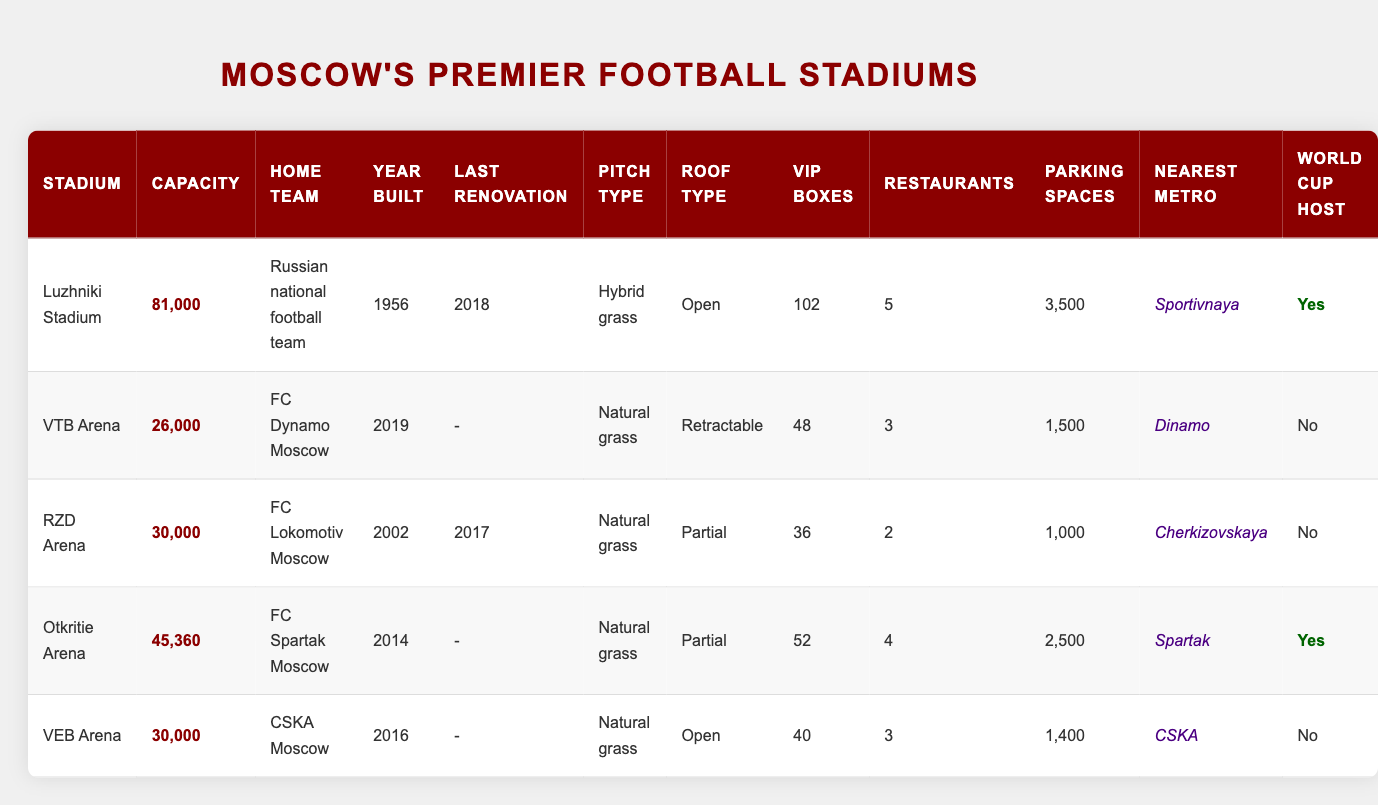What is the maximum capacity among Moscow's football stadiums? The table lists the capacities of all stadiums. Luzhniki Stadium has the highest capacity of 81,000, compared to the other stadiums: VTB Arena (26,000), RZD Arena (30,000), Otkritie Arena (45,360), and VEB Arena (30,000). Therefore, the maximum capacity is 81,000.
Answer: 81,000 Which stadium has the most VIP boxes? The table shows that Luzhniki Stadium has 102 VIP boxes, which is higher than any other stadium: VTB Arena has 48, RZD Arena has 36, Otkritie Arena has 52, and VEB Arena has 40. Thus, the stadium with the most VIP boxes is Luzhniki Stadium.
Answer: Luzhniki Stadium How many parking spaces are there in total among all stadiums? Adding the parking spaces from each stadium yields: 3,500 (Luzhniki) + 1,500 (VTB) + 1,000 (RZD) + 2,500 (Otkritie) + 1,400 (VEB) = 10,900. Therefore, the total number of parking spaces is 10,900.
Answer: 10,900 Is VTB Arena a World Cup host stadium? The table indicates that VTB Arena is not a World Cup host, as the column for World Cup Host shows "No" for this stadium.
Answer: No How many more restaurants does Otkritie Arena have compared to RZD Arena? Otkritie Arena has 4 restaurants, while RZD Arena has 2. The difference is calculated as 4 - 2 = 2. Therefore, Otkritie Arena has 2 more restaurants than RZD Arena.
Answer: 2 What type of roof does the stadium with the highest capacity have? Luzhniki Stadium, the stadium with the highest capacity of 81,000, has an 'Open' roof type, as stated in the table.
Answer: Open List the home teams of all the stadiums that hosted the World Cup. The table indicates that only Luzhniki Stadium and Otkritie Arena hosted the World Cup. Their respective home teams are: Russian national football team (Luzhniki) and FC Spartak Moscow (Otkritie). Therefore, the home teams of the World Cup host stadiums are Russian national football team and FC Spartak Moscow.
Answer: Russian national football team, FC Spartak Moscow What is the average capacity of the stadiums that are not World Cup hosts? The non-host stadiums are VTB Arena (26,000), RZD Arena (30,000), VEB Arena (30,000). Their total capacity is 26,000 + 30,000 + 30,000 = 86,000. There are 3 such stadiums, so the average is 86,000 / 3 = 28,666.67. Therefore, the average capacity is 28,666.67.
Answer: 28,666.67 